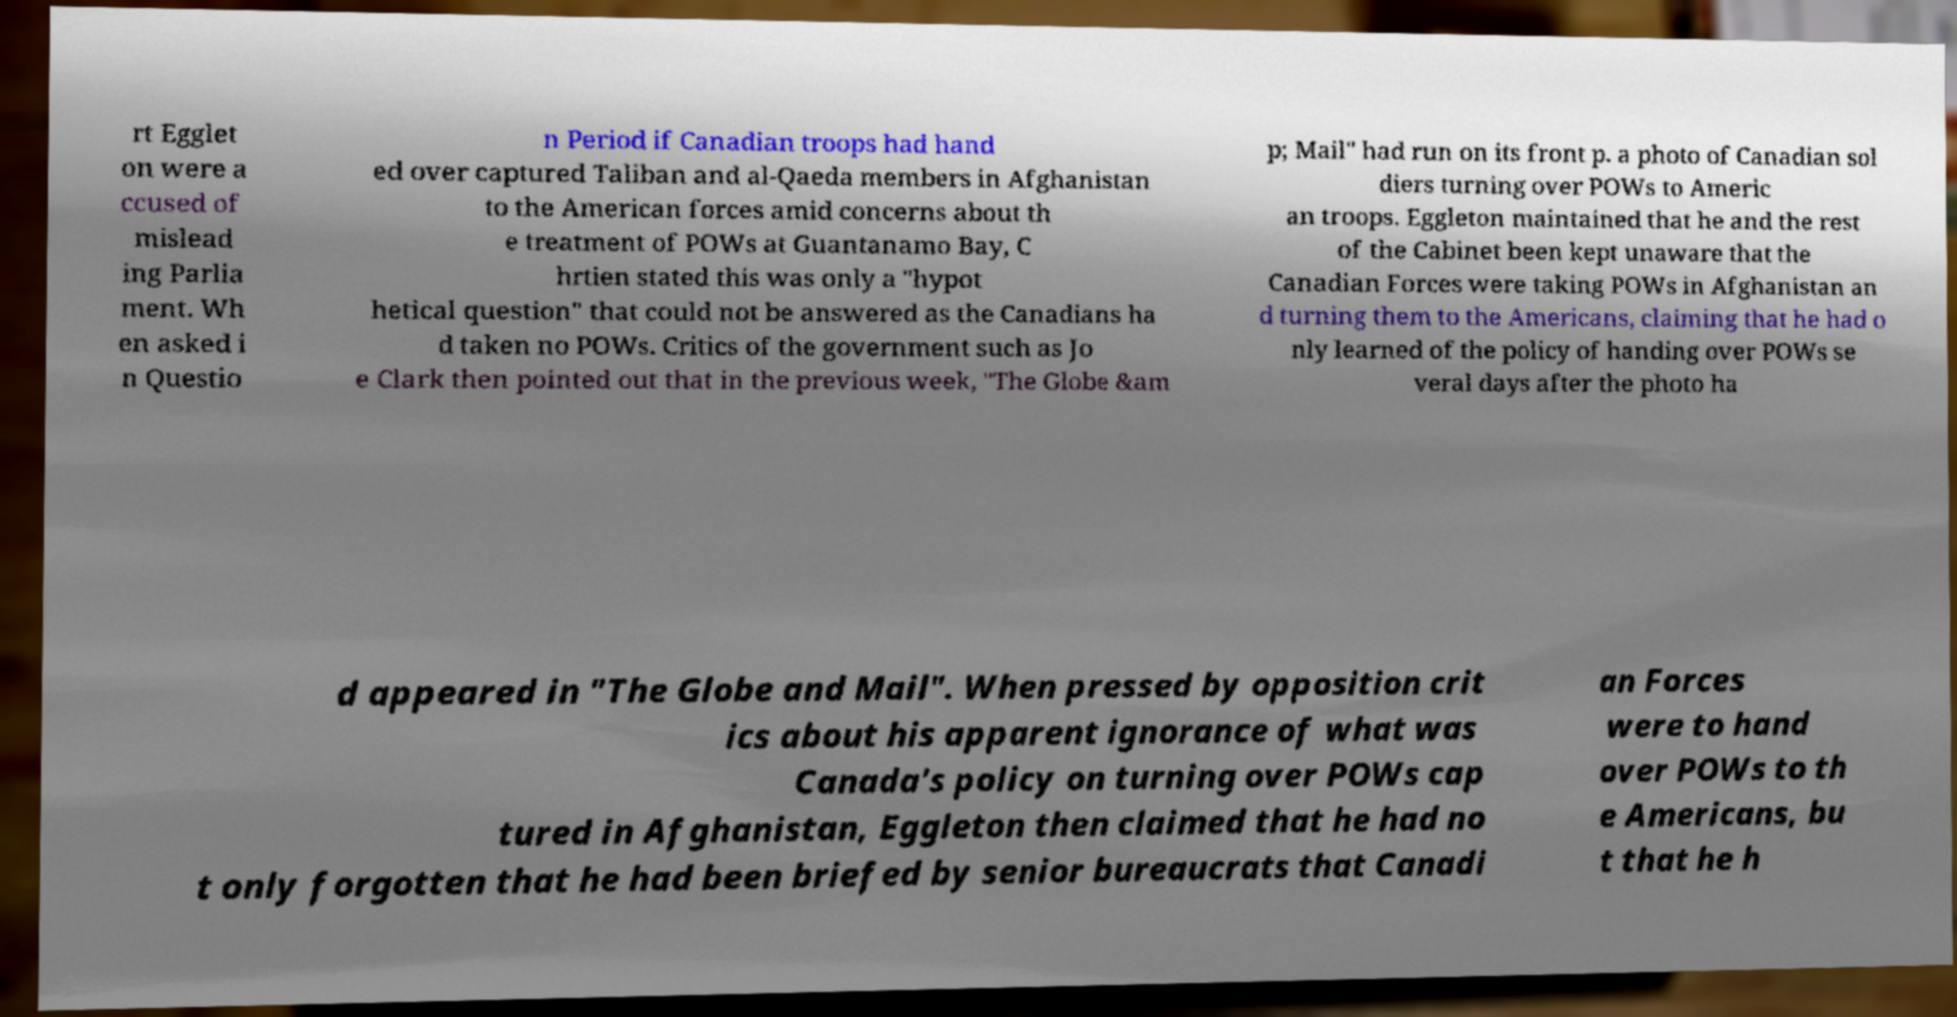There's text embedded in this image that I need extracted. Can you transcribe it verbatim? rt Egglet on were a ccused of mislead ing Parlia ment. Wh en asked i n Questio n Period if Canadian troops had hand ed over captured Taliban and al-Qaeda members in Afghanistan to the American forces amid concerns about th e treatment of POWs at Guantanamo Bay, C hrtien stated this was only a "hypot hetical question" that could not be answered as the Canadians ha d taken no POWs. Critics of the government such as Jo e Clark then pointed out that in the previous week, "The Globe &am p; Mail" had run on its front p. a photo of Canadian sol diers turning over POWs to Americ an troops. Eggleton maintained that he and the rest of the Cabinet been kept unaware that the Canadian Forces were taking POWs in Afghanistan an d turning them to the Americans, claiming that he had o nly learned of the policy of handing over POWs se veral days after the photo ha d appeared in "The Globe and Mail". When pressed by opposition crit ics about his apparent ignorance of what was Canada's policy on turning over POWs cap tured in Afghanistan, Eggleton then claimed that he had no t only forgotten that he had been briefed by senior bureaucrats that Canadi an Forces were to hand over POWs to th e Americans, bu t that he h 